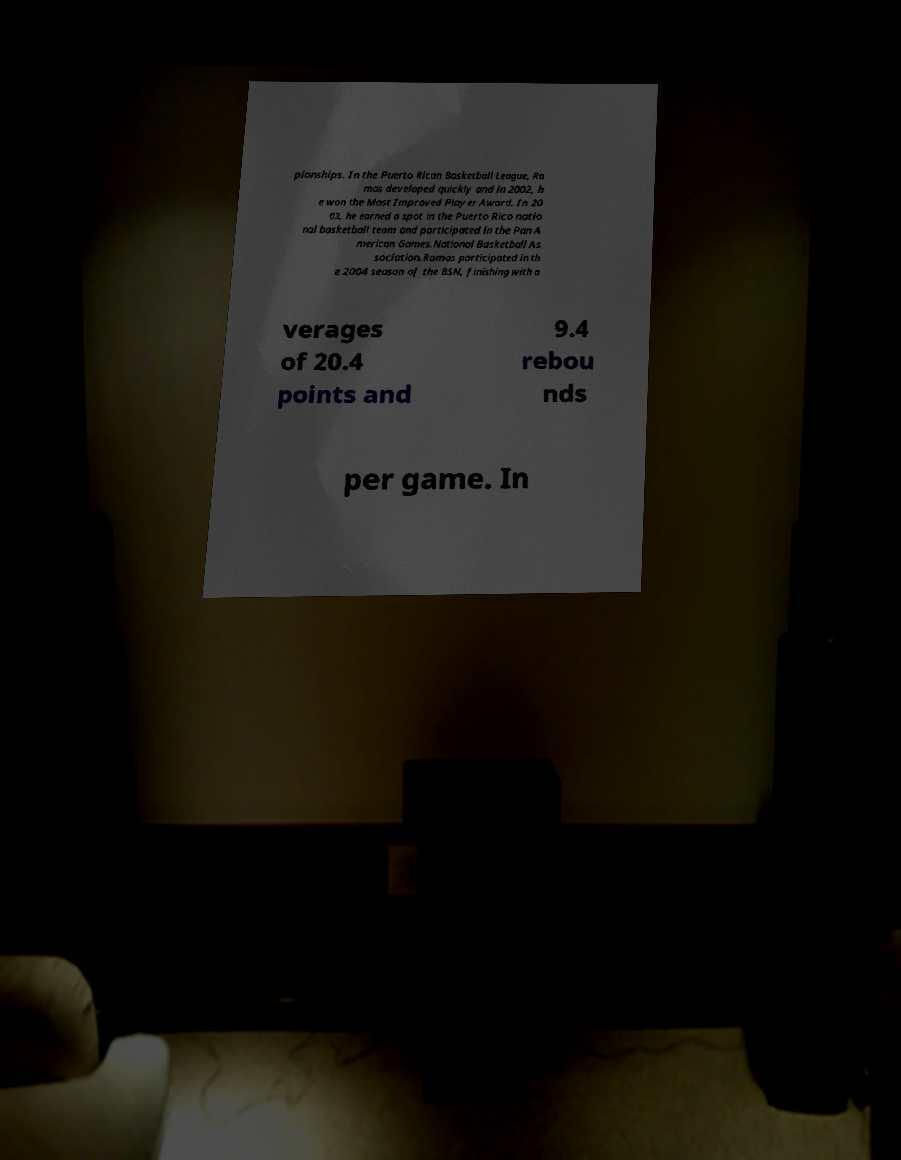I need the written content from this picture converted into text. Can you do that? pionships. In the Puerto Rican Basketball League, Ra mos developed quickly and in 2002, h e won the Most Improved Player Award. In 20 03, he earned a spot in the Puerto Rico natio nal basketball team and participated in the Pan A merican Games.National Basketball As sociation.Ramos participated in th e 2004 season of the BSN, finishing with a verages of 20.4 points and 9.4 rebou nds per game. In 